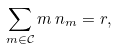Convert formula to latex. <formula><loc_0><loc_0><loc_500><loc_500>\sum _ { m \in \mathcal { C } } m \, n _ { m } = r ,</formula> 